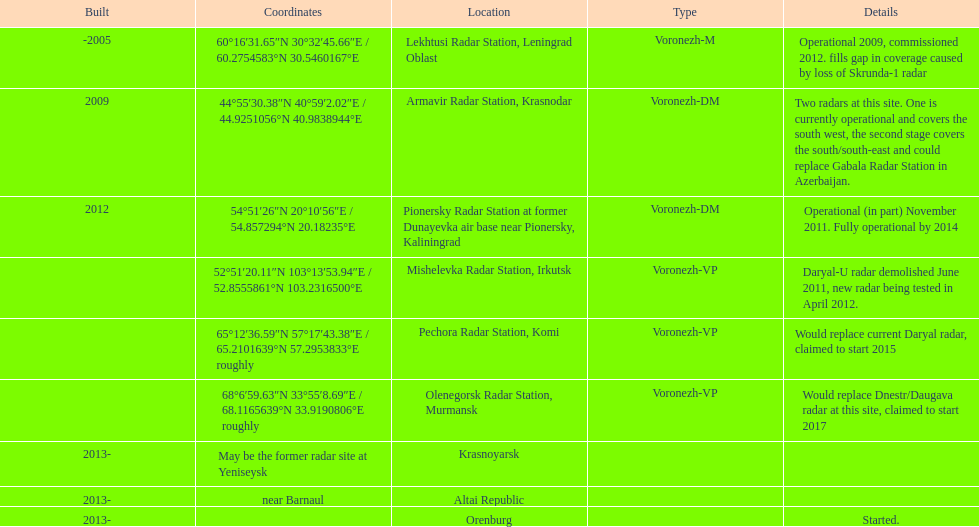How long did it take the pionersky radar station to go from partially operational to fully operational? 3 years. 